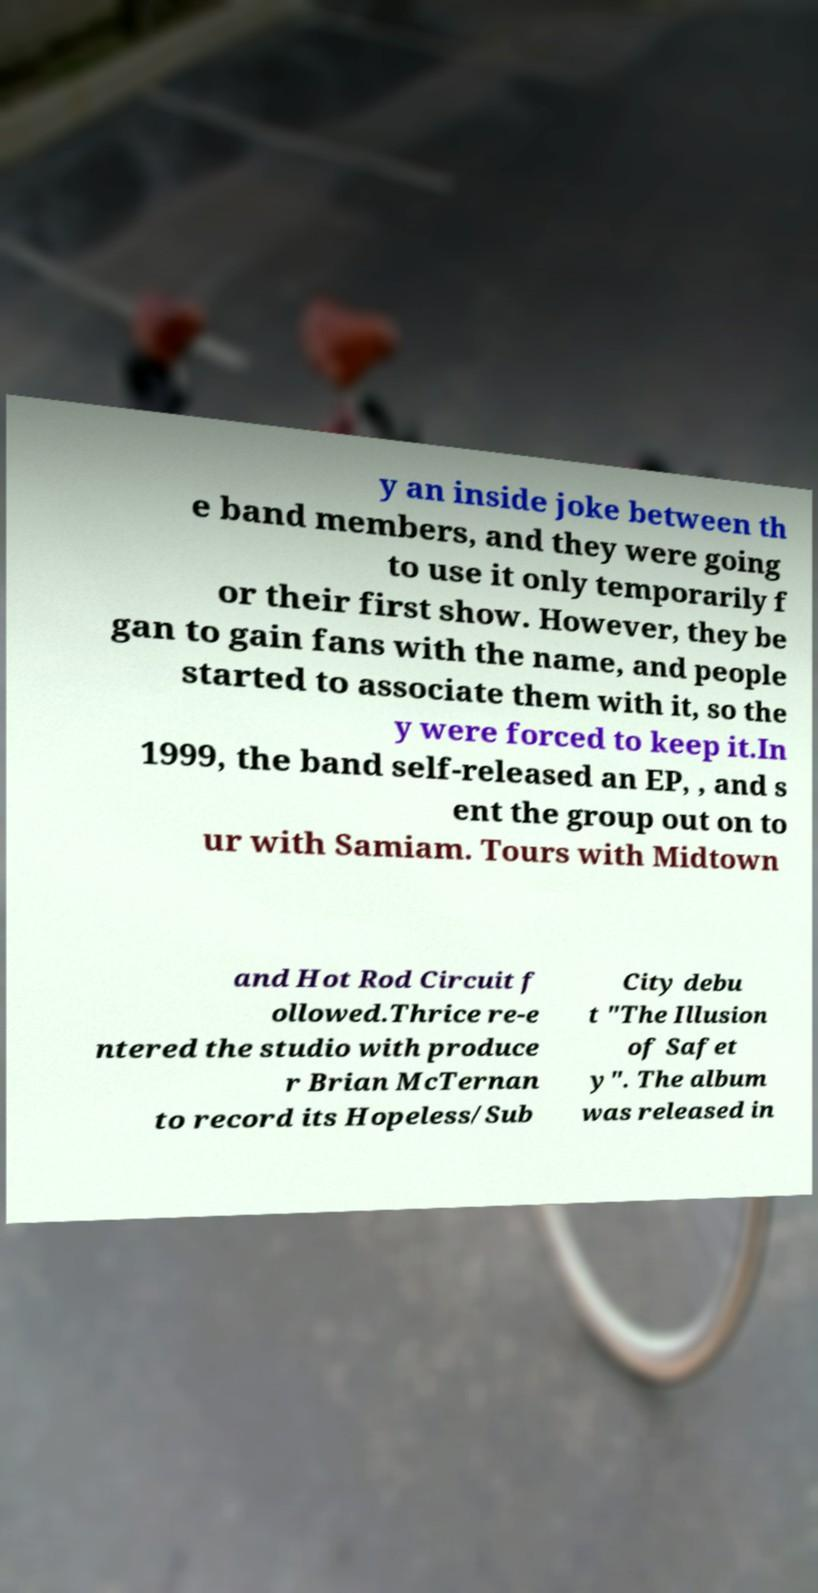For documentation purposes, I need the text within this image transcribed. Could you provide that? y an inside joke between th e band members, and they were going to use it only temporarily f or their first show. However, they be gan to gain fans with the name, and people started to associate them with it, so the y were forced to keep it.In 1999, the band self-released an EP, , and s ent the group out on to ur with Samiam. Tours with Midtown and Hot Rod Circuit f ollowed.Thrice re-e ntered the studio with produce r Brian McTernan to record its Hopeless/Sub City debu t "The Illusion of Safet y". The album was released in 